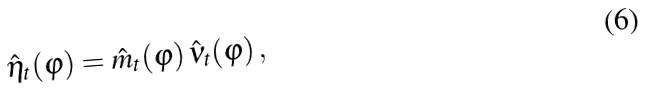<formula> <loc_0><loc_0><loc_500><loc_500>\hat { \eta } _ { t } ( \varphi ) = \hat { m } _ { t } ( \varphi ) \, \hat { \nu } _ { t } ( \varphi ) \, ,</formula> 